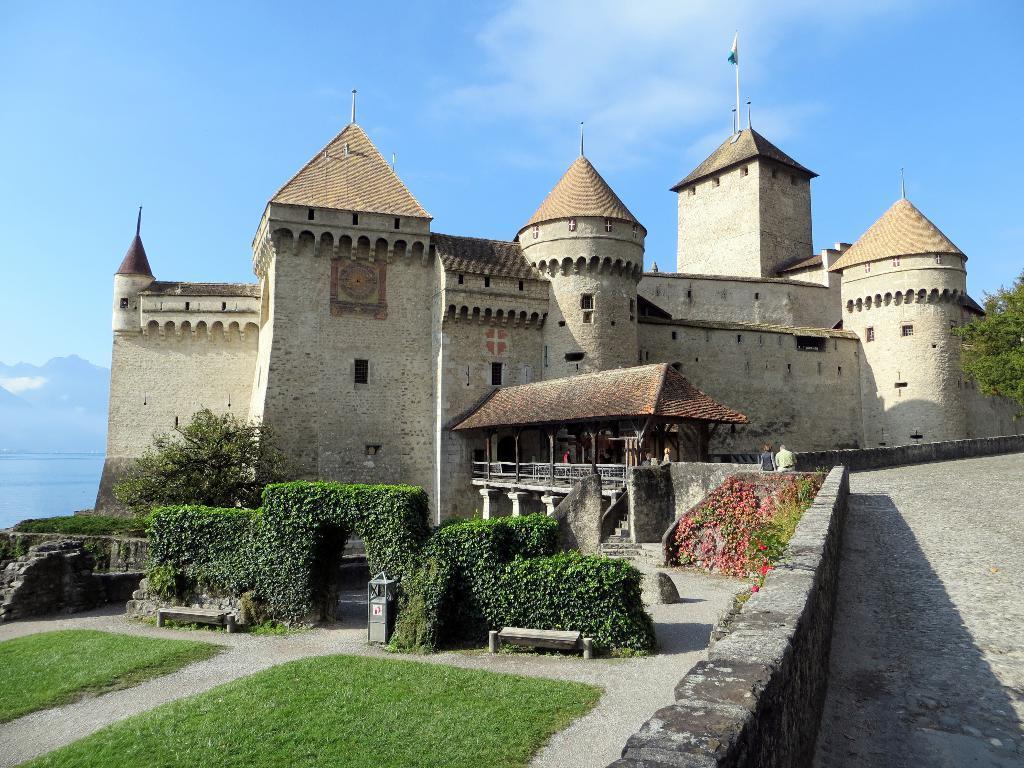Describe this image in one or two sentences. In this image I can see a building in the centre. On the left side of the image I can see grass, number of plants and number of flowers. On the right side of the image I can see a tree. In the background I can see clouds and the sky. On the top side of the image I can see a flag on the building and on the left side of the image I can see mountains. 